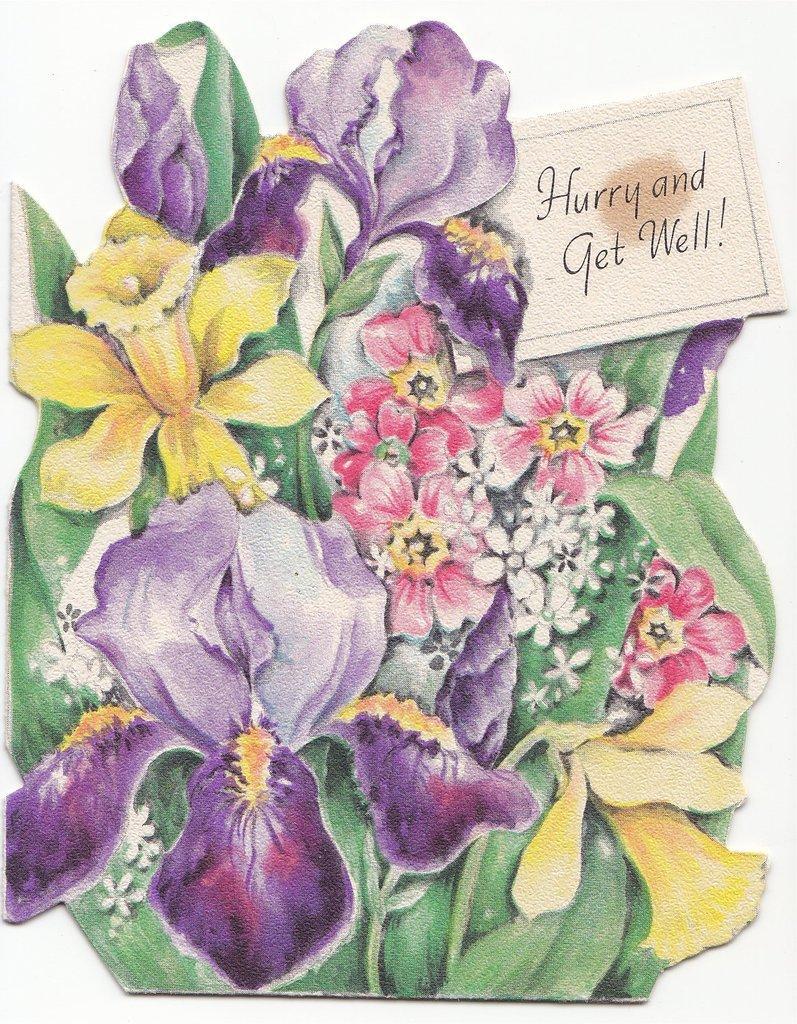Can you describe this image briefly? In this image we can see a picture of a bouquet with a card and some text on it. 